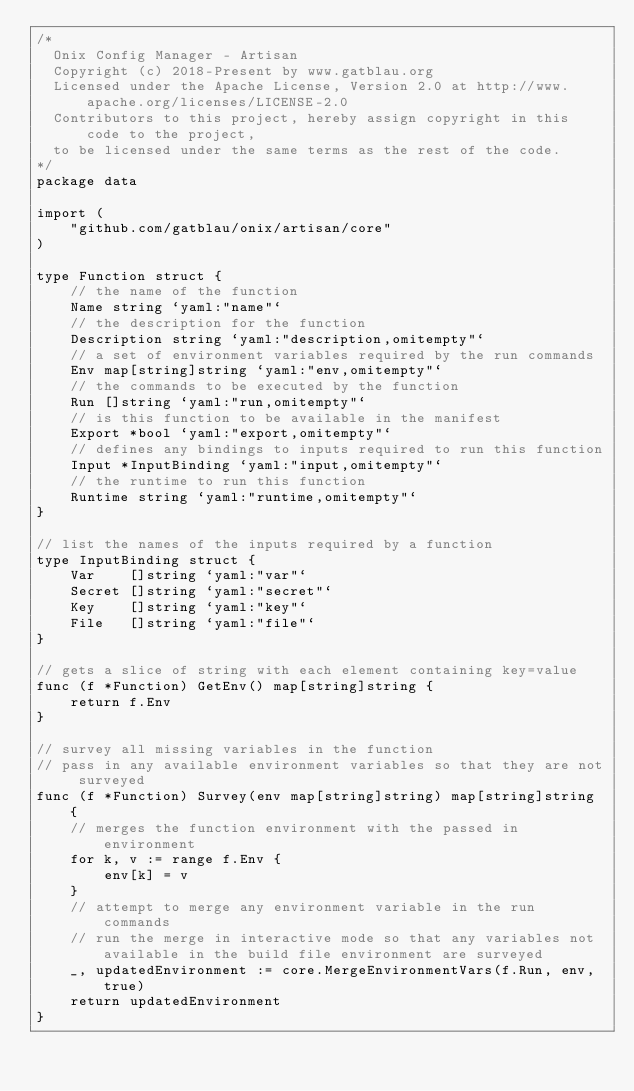Convert code to text. <code><loc_0><loc_0><loc_500><loc_500><_Go_>/*
  Onix Config Manager - Artisan
  Copyright (c) 2018-Present by www.gatblau.org
  Licensed under the Apache License, Version 2.0 at http://www.apache.org/licenses/LICENSE-2.0
  Contributors to this project, hereby assign copyright in this code to the project,
  to be licensed under the same terms as the rest of the code.
*/
package data

import (
	"github.com/gatblau/onix/artisan/core"
)

type Function struct {
	// the name of the function
	Name string `yaml:"name"`
	// the description for the function
	Description string `yaml:"description,omitempty"`
	// a set of environment variables required by the run commands
	Env map[string]string `yaml:"env,omitempty"`
	// the commands to be executed by the function
	Run []string `yaml:"run,omitempty"`
	// is this function to be available in the manifest
	Export *bool `yaml:"export,omitempty"`
	// defines any bindings to inputs required to run this function
	Input *InputBinding `yaml:"input,omitempty"`
	// the runtime to run this function
	Runtime string `yaml:"runtime,omitempty"`
}

// list the names of the inputs required by a function
type InputBinding struct {
	Var    []string `yaml:"var"`
	Secret []string `yaml:"secret"`
	Key    []string `yaml:"key"`
	File   []string `yaml:"file"`
}

// gets a slice of string with each element containing key=value
func (f *Function) GetEnv() map[string]string {
	return f.Env
}

// survey all missing variables in the function
// pass in any available environment variables so that they are not surveyed
func (f *Function) Survey(env map[string]string) map[string]string {
	// merges the function environment with the passed in environment
	for k, v := range f.Env {
		env[k] = v
	}
	// attempt to merge any environment variable in the run commands
	// run the merge in interactive mode so that any variables not available in the build file environment are surveyed
	_, updatedEnvironment := core.MergeEnvironmentVars(f.Run, env, true)
	return updatedEnvironment
}
</code> 